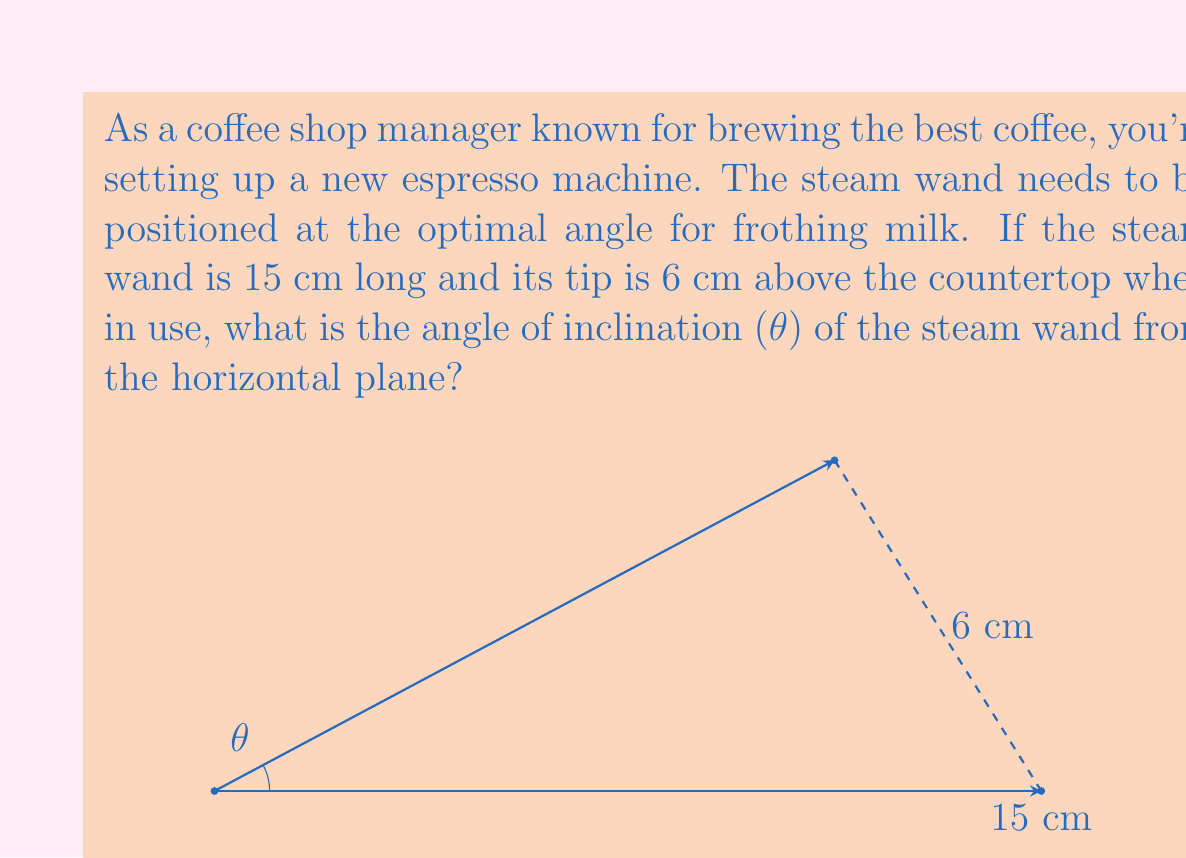What is the answer to this math problem? To solve this problem, we can use trigonometry, specifically the sine function. Let's break it down step-by-step:

1) We have a right triangle formed by:
   - The horizontal countertop (adjacent to θ)
   - The vertical height of the steam wand tip (opposite to θ)
   - The steam wand itself (hypotenuse)

2) We know:
   - The length of the steam wand (hypotenuse) = 15 cm
   - The height of the steam wand tip (opposite) = 6 cm

3) To find the angle θ, we can use the sine function:

   $$\sin(θ) = \frac{\text{opposite}}{\text{hypotenuse}} = \frac{6}{15} = \frac{2}{5} = 0.4$$

4) To get the angle θ, we need to take the inverse sine (arcsin) of both sides:

   $$θ = \arcsin(0.4)$$

5) Using a calculator or trigonometric tables, we can find that:

   $$θ ≈ 23.5786°$$

6) Rounding to the nearest tenth of a degree:

   $$θ ≈ 23.6°$$

Therefore, the angle of inclination of the steam wand from the horizontal plane is approximately 23.6°.
Answer: $θ ≈ 23.6°$ 